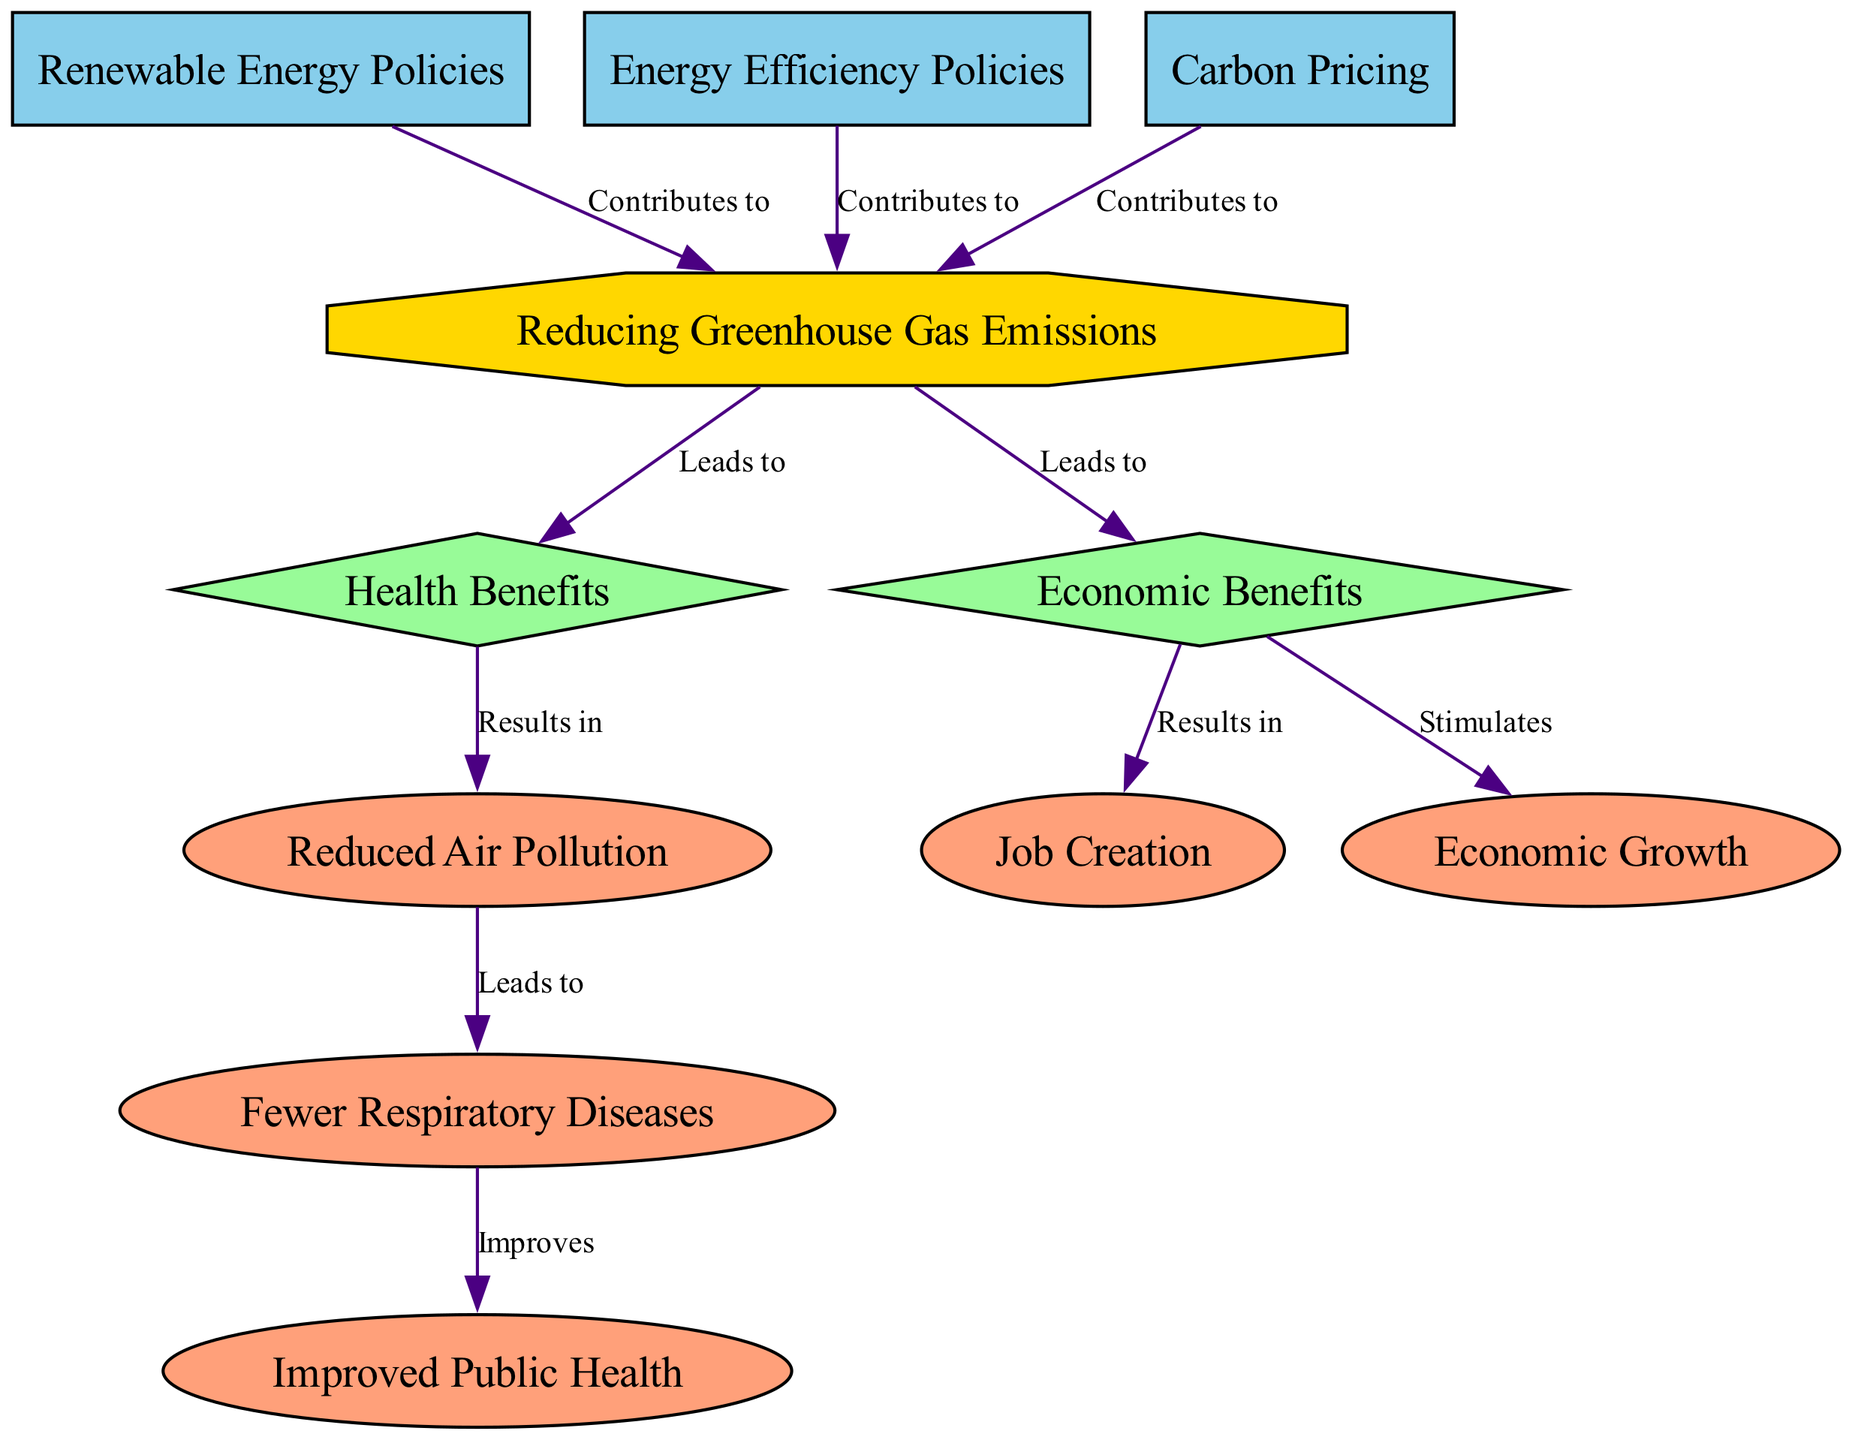What is the main goal of the diagram? The diagram has "Reducing Greenhouse Gas Emissions" as the main goal, which is indicated by its positioning and the octagon shape, signifying it as a goal node.
Answer: Reducing Greenhouse Gas Emissions How many policies are listed in the diagram? There are three policies indicated in the diagram: "Renewable Energy Policies," "Energy Efficiency Policies," and "Carbon Pricing," which can be counted from the rectangular nodes labeled as policies.
Answer: 3 What benefit results from reducing greenhouse gas emissions? The diagram specifies two benefits resulting from reducing greenhouse gas emissions: "Health Benefits" and "Economic Benefits," both of which are shown as diamond-shaped nodes.
Answer: Health Benefits, Economic Benefits Which outcome is linked to improved public health? The outcome "Improved Public Health" is connected to "Fewer Respiratory Diseases," which is indicated by the directional edge leading from the node for fewer respiratory diseases to improved public health.
Answer: Fewer Respiratory Diseases What outcome is stimulated by economic benefits? The economic benefits node has direct edges leading to "Job Creation" and "Economic Growth," indicating that both outcomes are stimulated by the economic benefits associated with reducing greenhouse gas emissions.
Answer: Job Creation, Economic Growth Which policy contributes to the goal of reducing greenhouse gas emissions? All three policies—"Renewable Energy Policies," "Energy Efficiency Policies," and "Carbon Pricing"—contribute to the goal as represented by the directed edges pointing from each policy node to the goal node.
Answer: Renewable Energy Policies, Energy Efficiency Policies, Carbon Pricing What leads to fewer respiratory diseases according to the diagram? The outcome "Fewer Respiratory Diseases" is indicated to be a consequence of "Reduced Air Pollution," which is shown in the diagram as leading from the air pollution outcome to the respiratory diseases outcome.
Answer: Reduced Air Pollution What is necessary to achieve improved public health in the context of the diagram? According to the flow of the diagram, achieving improved public health is necessary from the outcomes of "Fewer Respiratory Diseases," signifying that the latter directly improves public health.
Answer: Fewer Respiratory Diseases What type of node is "Health Benefits"? The node "Health Benefits" is categorized as a benefit, denoted by its diamond shape and the label specifying it as such within the diagram.
Answer: Benefit 